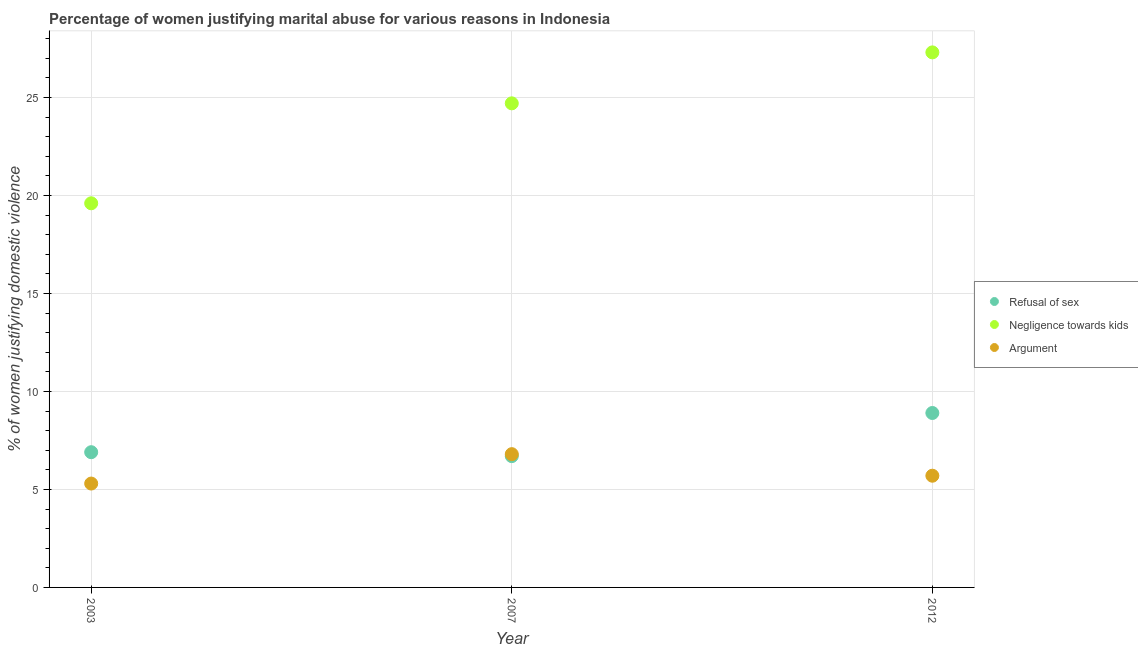How many different coloured dotlines are there?
Offer a terse response. 3. What is the percentage of women justifying domestic violence due to negligence towards kids in 2007?
Offer a terse response. 24.7. In which year was the percentage of women justifying domestic violence due to arguments maximum?
Your answer should be compact. 2007. In which year was the percentage of women justifying domestic violence due to refusal of sex minimum?
Your response must be concise. 2007. What is the difference between the percentage of women justifying domestic violence due to arguments in 2003 and the percentage of women justifying domestic violence due to refusal of sex in 2012?
Make the answer very short. -3.6. What is the average percentage of women justifying domestic violence due to arguments per year?
Provide a succinct answer. 5.93. In the year 2012, what is the difference between the percentage of women justifying domestic violence due to refusal of sex and percentage of women justifying domestic violence due to negligence towards kids?
Your response must be concise. -18.4. In how many years, is the percentage of women justifying domestic violence due to refusal of sex greater than 5 %?
Ensure brevity in your answer.  3. What is the ratio of the percentage of women justifying domestic violence due to arguments in 2003 to that in 2007?
Make the answer very short. 0.78. Is the percentage of women justifying domestic violence due to arguments in 2007 less than that in 2012?
Give a very brief answer. No. What is the difference between the highest and the second highest percentage of women justifying domestic violence due to arguments?
Your response must be concise. 1.1. What is the difference between the highest and the lowest percentage of women justifying domestic violence due to arguments?
Give a very brief answer. 1.5. Is the sum of the percentage of women justifying domestic violence due to arguments in 2007 and 2012 greater than the maximum percentage of women justifying domestic violence due to negligence towards kids across all years?
Ensure brevity in your answer.  No. Does the percentage of women justifying domestic violence due to refusal of sex monotonically increase over the years?
Keep it short and to the point. No. Is the percentage of women justifying domestic violence due to refusal of sex strictly greater than the percentage of women justifying domestic violence due to arguments over the years?
Give a very brief answer. No. Is the percentage of women justifying domestic violence due to negligence towards kids strictly less than the percentage of women justifying domestic violence due to arguments over the years?
Your response must be concise. No. How many dotlines are there?
Offer a terse response. 3. Where does the legend appear in the graph?
Provide a short and direct response. Center right. How many legend labels are there?
Your answer should be compact. 3. How are the legend labels stacked?
Offer a very short reply. Vertical. What is the title of the graph?
Offer a terse response. Percentage of women justifying marital abuse for various reasons in Indonesia. Does "Neonatal" appear as one of the legend labels in the graph?
Provide a succinct answer. No. What is the label or title of the X-axis?
Ensure brevity in your answer.  Year. What is the label or title of the Y-axis?
Keep it short and to the point. % of women justifying domestic violence. What is the % of women justifying domestic violence in Negligence towards kids in 2003?
Your answer should be compact. 19.6. What is the % of women justifying domestic violence of Negligence towards kids in 2007?
Ensure brevity in your answer.  24.7. What is the % of women justifying domestic violence of Negligence towards kids in 2012?
Provide a short and direct response. 27.3. What is the % of women justifying domestic violence in Argument in 2012?
Keep it short and to the point. 5.7. Across all years, what is the maximum % of women justifying domestic violence of Negligence towards kids?
Make the answer very short. 27.3. Across all years, what is the maximum % of women justifying domestic violence in Argument?
Your answer should be compact. 6.8. Across all years, what is the minimum % of women justifying domestic violence in Negligence towards kids?
Provide a succinct answer. 19.6. What is the total % of women justifying domestic violence of Refusal of sex in the graph?
Your response must be concise. 22.5. What is the total % of women justifying domestic violence of Negligence towards kids in the graph?
Your answer should be compact. 71.6. What is the difference between the % of women justifying domestic violence of Refusal of sex in 2003 and that in 2007?
Your answer should be compact. 0.2. What is the difference between the % of women justifying domestic violence in Refusal of sex in 2003 and that in 2012?
Keep it short and to the point. -2. What is the difference between the % of women justifying domestic violence in Argument in 2003 and that in 2012?
Provide a succinct answer. -0.4. What is the difference between the % of women justifying domestic violence in Refusal of sex in 2007 and that in 2012?
Your answer should be compact. -2.2. What is the difference between the % of women justifying domestic violence of Argument in 2007 and that in 2012?
Your answer should be very brief. 1.1. What is the difference between the % of women justifying domestic violence in Refusal of sex in 2003 and the % of women justifying domestic violence in Negligence towards kids in 2007?
Ensure brevity in your answer.  -17.8. What is the difference between the % of women justifying domestic violence of Negligence towards kids in 2003 and the % of women justifying domestic violence of Argument in 2007?
Make the answer very short. 12.8. What is the difference between the % of women justifying domestic violence of Refusal of sex in 2003 and the % of women justifying domestic violence of Negligence towards kids in 2012?
Keep it short and to the point. -20.4. What is the difference between the % of women justifying domestic violence in Refusal of sex in 2007 and the % of women justifying domestic violence in Negligence towards kids in 2012?
Your response must be concise. -20.6. What is the difference between the % of women justifying domestic violence of Negligence towards kids in 2007 and the % of women justifying domestic violence of Argument in 2012?
Give a very brief answer. 19. What is the average % of women justifying domestic violence in Negligence towards kids per year?
Ensure brevity in your answer.  23.87. What is the average % of women justifying domestic violence of Argument per year?
Give a very brief answer. 5.93. In the year 2003, what is the difference between the % of women justifying domestic violence of Refusal of sex and % of women justifying domestic violence of Negligence towards kids?
Your response must be concise. -12.7. In the year 2003, what is the difference between the % of women justifying domestic violence in Negligence towards kids and % of women justifying domestic violence in Argument?
Offer a terse response. 14.3. In the year 2007, what is the difference between the % of women justifying domestic violence in Refusal of sex and % of women justifying domestic violence in Negligence towards kids?
Your answer should be very brief. -18. In the year 2007, what is the difference between the % of women justifying domestic violence of Refusal of sex and % of women justifying domestic violence of Argument?
Your answer should be very brief. -0.1. In the year 2007, what is the difference between the % of women justifying domestic violence in Negligence towards kids and % of women justifying domestic violence in Argument?
Make the answer very short. 17.9. In the year 2012, what is the difference between the % of women justifying domestic violence in Refusal of sex and % of women justifying domestic violence in Negligence towards kids?
Your response must be concise. -18.4. In the year 2012, what is the difference between the % of women justifying domestic violence in Refusal of sex and % of women justifying domestic violence in Argument?
Keep it short and to the point. 3.2. In the year 2012, what is the difference between the % of women justifying domestic violence of Negligence towards kids and % of women justifying domestic violence of Argument?
Your answer should be compact. 21.6. What is the ratio of the % of women justifying domestic violence in Refusal of sex in 2003 to that in 2007?
Provide a short and direct response. 1.03. What is the ratio of the % of women justifying domestic violence of Negligence towards kids in 2003 to that in 2007?
Provide a succinct answer. 0.79. What is the ratio of the % of women justifying domestic violence in Argument in 2003 to that in 2007?
Your response must be concise. 0.78. What is the ratio of the % of women justifying domestic violence in Refusal of sex in 2003 to that in 2012?
Provide a short and direct response. 0.78. What is the ratio of the % of women justifying domestic violence in Negligence towards kids in 2003 to that in 2012?
Offer a terse response. 0.72. What is the ratio of the % of women justifying domestic violence of Argument in 2003 to that in 2012?
Give a very brief answer. 0.93. What is the ratio of the % of women justifying domestic violence in Refusal of sex in 2007 to that in 2012?
Ensure brevity in your answer.  0.75. What is the ratio of the % of women justifying domestic violence in Negligence towards kids in 2007 to that in 2012?
Your answer should be very brief. 0.9. What is the ratio of the % of women justifying domestic violence of Argument in 2007 to that in 2012?
Your answer should be compact. 1.19. What is the difference between the highest and the second highest % of women justifying domestic violence of Argument?
Your answer should be very brief. 1.1. What is the difference between the highest and the lowest % of women justifying domestic violence in Refusal of sex?
Make the answer very short. 2.2. What is the difference between the highest and the lowest % of women justifying domestic violence in Negligence towards kids?
Make the answer very short. 7.7. 